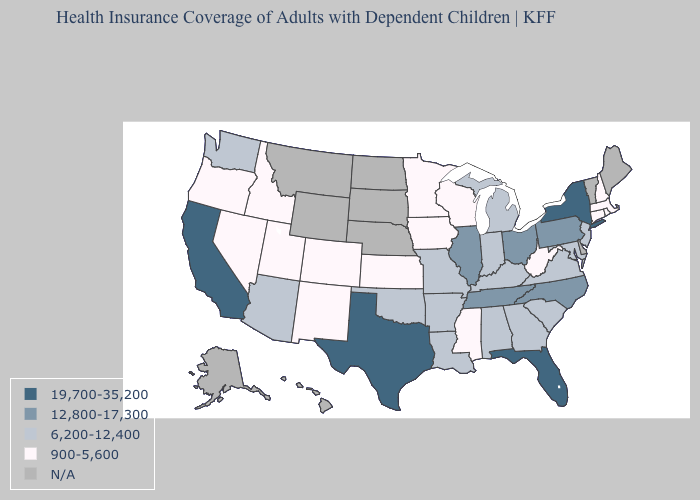Name the states that have a value in the range 12,800-17,300?
Keep it brief. Illinois, North Carolina, Ohio, Pennsylvania, Tennessee. What is the highest value in states that border Nebraska?
Write a very short answer. 6,200-12,400. What is the value of Arkansas?
Keep it brief. 6,200-12,400. What is the value of Minnesota?
Quick response, please. 900-5,600. Does the first symbol in the legend represent the smallest category?
Quick response, please. No. Which states have the lowest value in the South?
Short answer required. Mississippi, West Virginia. Name the states that have a value in the range 6,200-12,400?
Concise answer only. Alabama, Arizona, Arkansas, Georgia, Indiana, Kentucky, Louisiana, Maryland, Michigan, Missouri, New Jersey, Oklahoma, South Carolina, Virginia, Washington. What is the highest value in the MidWest ?
Be succinct. 12,800-17,300. What is the value of Colorado?
Give a very brief answer. 900-5,600. Which states have the highest value in the USA?
Write a very short answer. California, Florida, New York, Texas. What is the value of Michigan?
Quick response, please. 6,200-12,400. Among the states that border Texas , does New Mexico have the lowest value?
Quick response, please. Yes. How many symbols are there in the legend?
Concise answer only. 5. 